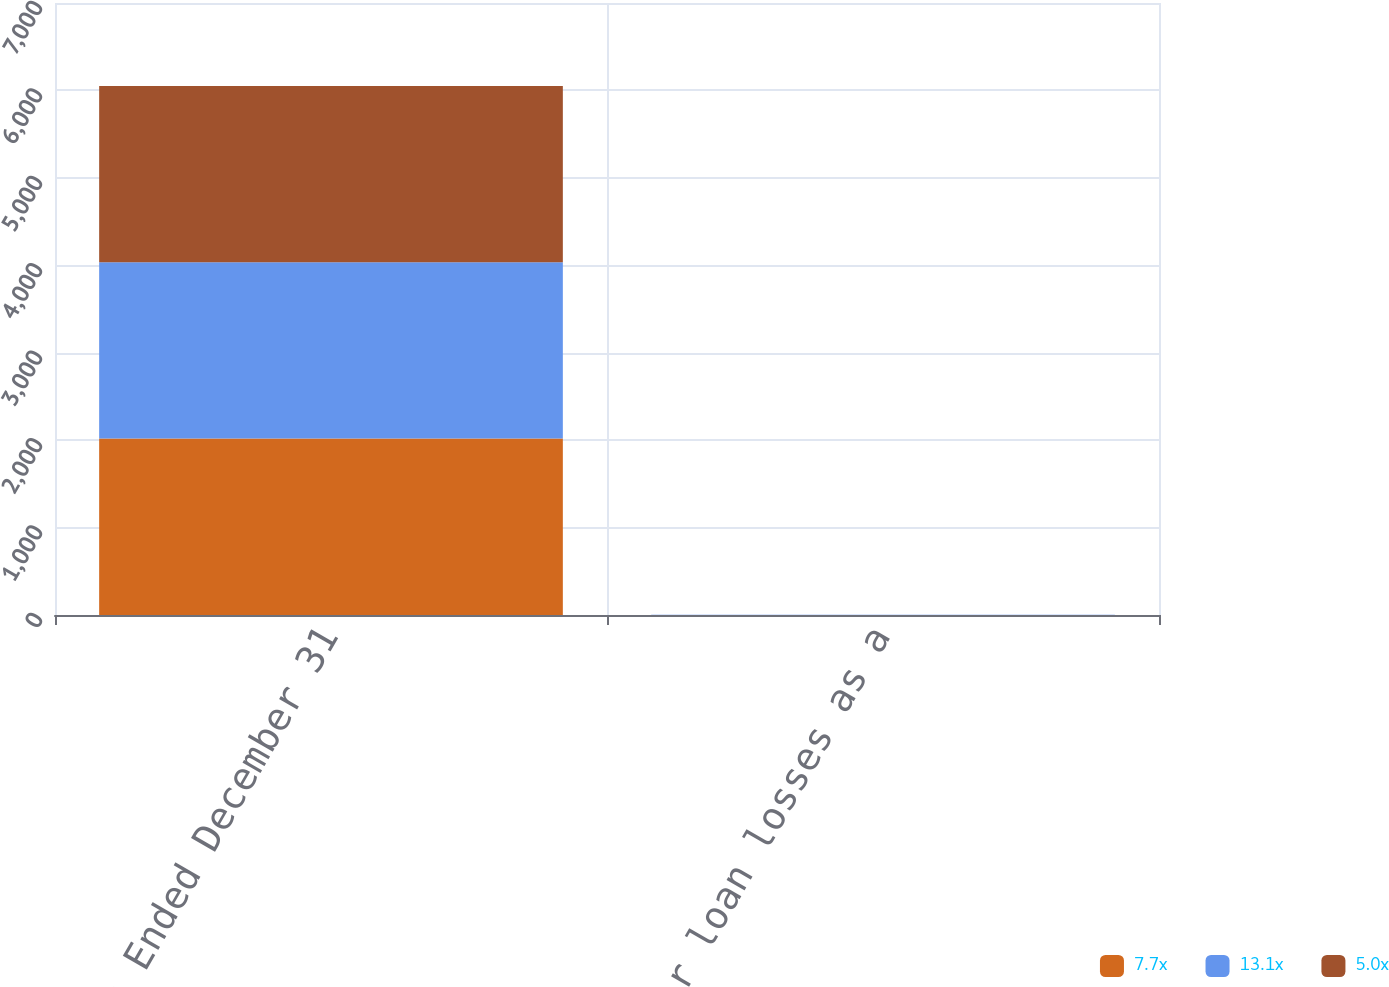<chart> <loc_0><loc_0><loc_500><loc_500><stacked_bar_chart><ecel><fcel>Years Ended December 31<fcel>Allowance for loan losses as a<nl><fcel>7.7x<fcel>2018<fcel>1.34<nl><fcel>13.1x<fcel>2017<fcel>1.45<nl><fcel>5.0x<fcel>2016<fcel>1.49<nl></chart> 